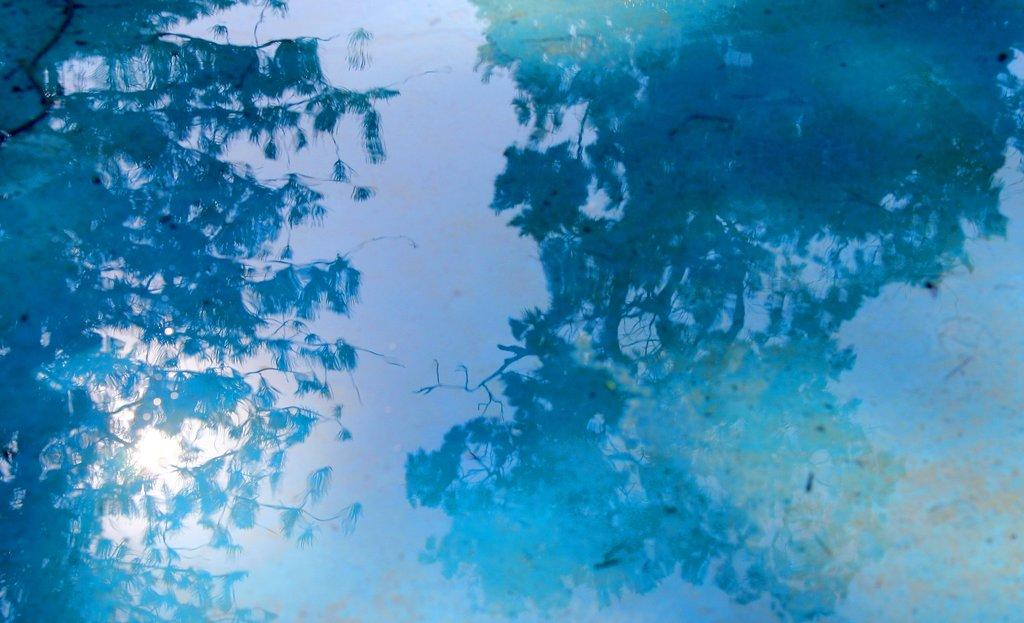What style does the image resemble? The image resembles a painting. What can be seen in the water's reflection? The reflection in the water shows the sky, a tree, and the sun. What is the title of the painting in the image? There is no title provided for the painting in the image. What type of engine can be seen powering a vehicle in the image? There is no vehicle or engine present in the image. Can you tell me where the nearest hospital is located in the image? There is no hospital or indication of its location in the image. 